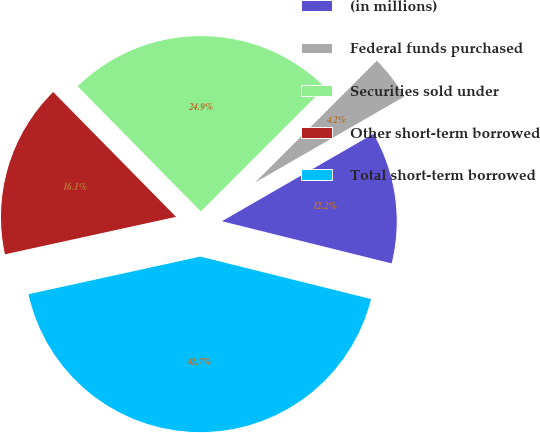Convert chart to OTSL. <chart><loc_0><loc_0><loc_500><loc_500><pie_chart><fcel>(in millions)<fcel>Federal funds purchased<fcel>Securities sold under<fcel>Other short-term borrowed<fcel>Total short-term borrowed<nl><fcel>12.2%<fcel>4.18%<fcel>24.87%<fcel>16.06%<fcel>42.69%<nl></chart> 